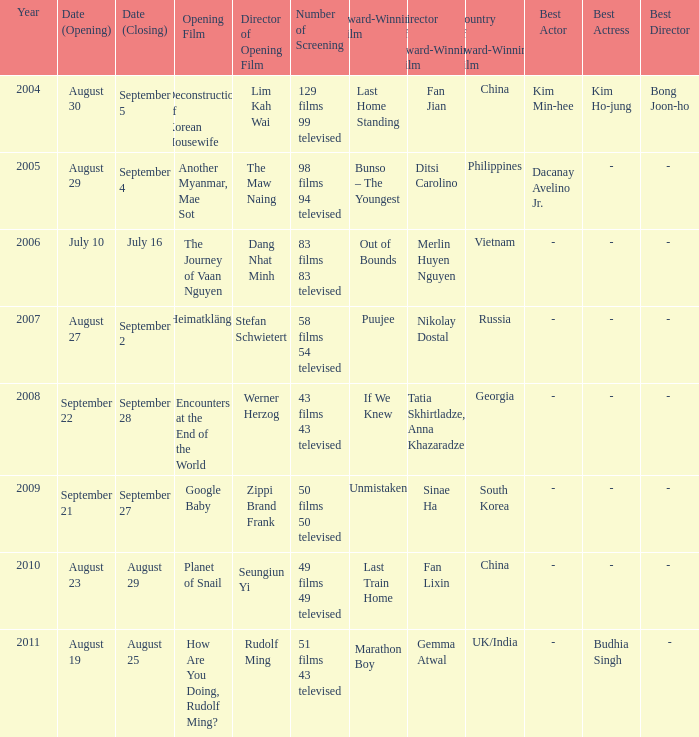Would you be able to parse every entry in this table? {'header': ['Year', 'Date (Opening)', 'Date (Closing)', 'Opening Film', 'Director of Opening Film', 'Number of Screening', 'Award-Winning Film', 'Director of Award-Winning Film', 'Country of Award-Winning Film', 'Best Actor', 'Best Actress', 'Best Director'], 'rows': [['2004', 'August 30', 'September 5', 'Deconstruction of Korean Housewife', 'Lim Kah Wai', '129 films 99 televised', 'Last Home Standing', 'Fan Jian', 'China', 'Kim Min-hee', 'Kim Ho-jung', 'Bong Joon-ho'], ['2005', 'August 29', 'September 4', 'Another Myanmar, Mae Sot', 'The Maw Naing', '98 films 94 televised', 'Bunso – The Youngest', 'Ditsi Carolino', 'Philippines', 'Dacanay Avelino Jr.', '-', '- '], ['2006', 'July 10', 'July 16', 'The Journey of Vaan Nguyen', 'Dang Nhat Minh', '83 films 83 televised', 'Out of Bounds', 'Merlin Huyen Nguyen', 'Vietnam', '-', '-', '- '], ['2007', 'August 27', 'September 2', 'Heimatklänge', 'Stefan Schwietert', '58 films 54 televised', 'Puujee', 'Nikolay Dostal', 'Russia', '-', '-', '- '], ['2008', 'September 22', 'September 28', 'Encounters at the End of the World', 'Werner Herzog', '43 films 43 televised', 'If We Knew', 'Tatia Skhirtladze, Anna Khazaradze', 'Georgia', '-', '-', '- '], ['2009', 'September 21', 'September 27', 'Google Baby', 'Zippi Brand Frank', '50 films 50 televised', 'Unmistaken', 'Sinae Ha', 'South Korea', '-', '-', '- '], ['2010', 'August 23', 'August 29', 'Planet of Snail', 'Seungiun Yi', '49 films 49 televised', 'Last Train Home', 'Fan Lixin', 'China', '-', '-', '- '], ['2011', 'August 19', 'August 25', 'How Are You Doing, Rudolf Ming?', 'Rudolf Ming', '51 films 43 televised', 'Marathon Boy', 'Gemma Atwal', 'UK/India', '-', 'Budhia Singh', '-']]} How many award-winning films have the opening film of encounters at the end of the world? 1.0. 